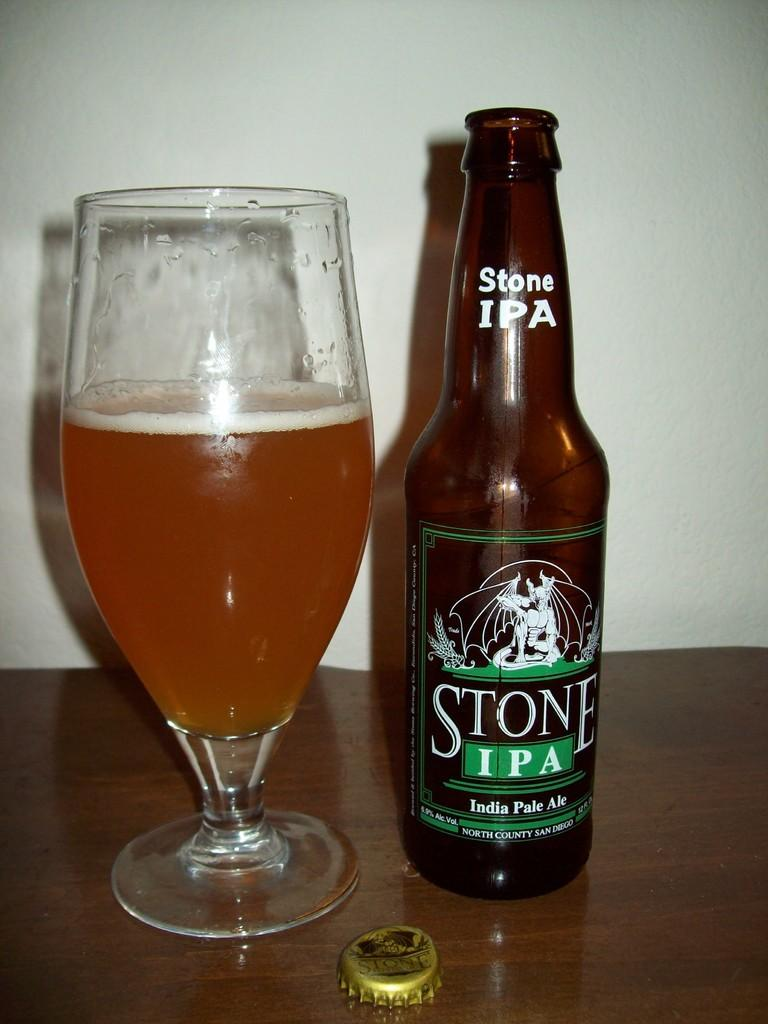<image>
Share a concise interpretation of the image provided. A beer glass is three quarters of the way full, on a wooden surface, next to an open bottle of Stone IPA, India Pale Ale. 